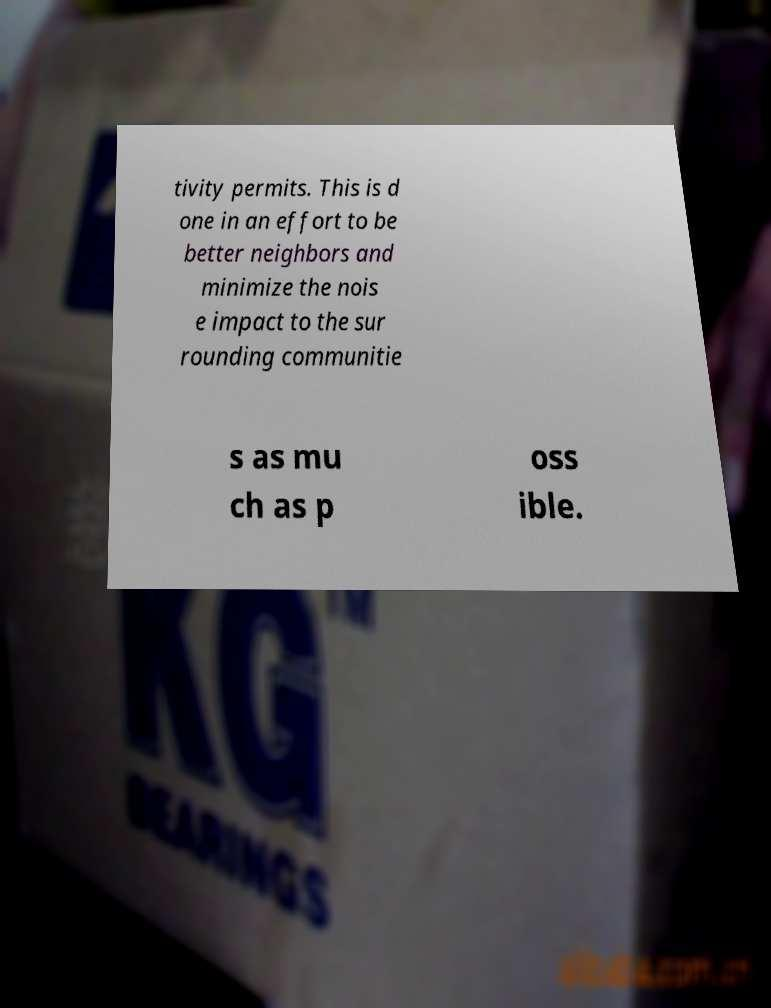Could you assist in decoding the text presented in this image and type it out clearly? tivity permits. This is d one in an effort to be better neighbors and minimize the nois e impact to the sur rounding communitie s as mu ch as p oss ible. 